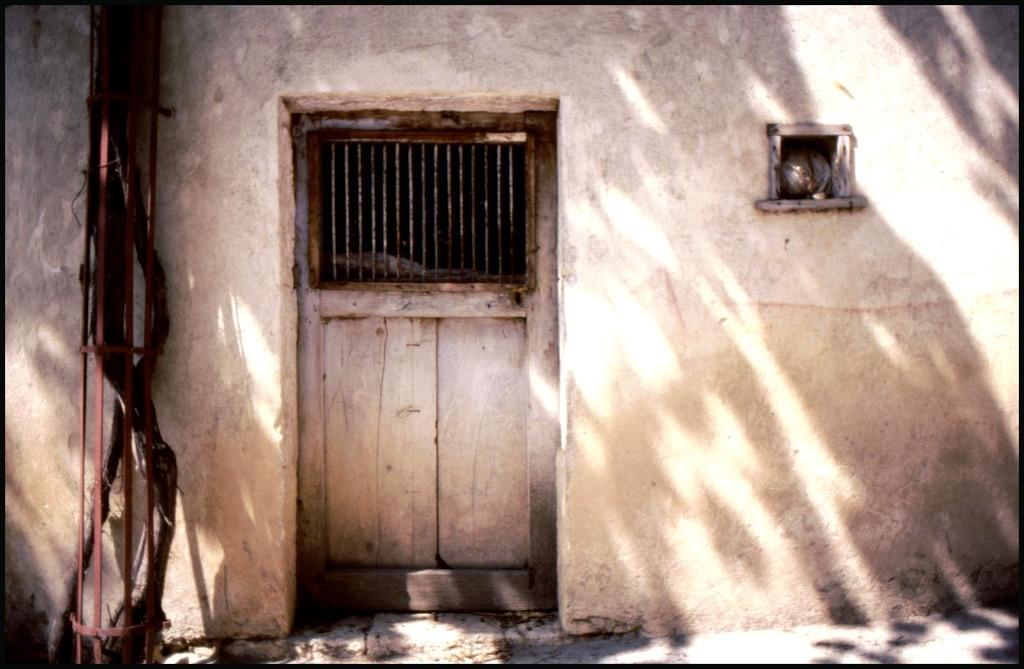What objects can be seen in the image? There are rods in the image. What structure is visible in the image? There is a door in the image. What can be seen in the background of the image? There is a wall in the background of the image. What type of treatment is being administered to the squirrel in the image? There is no squirrel present in the image, and therefore no treatment can be observed. 